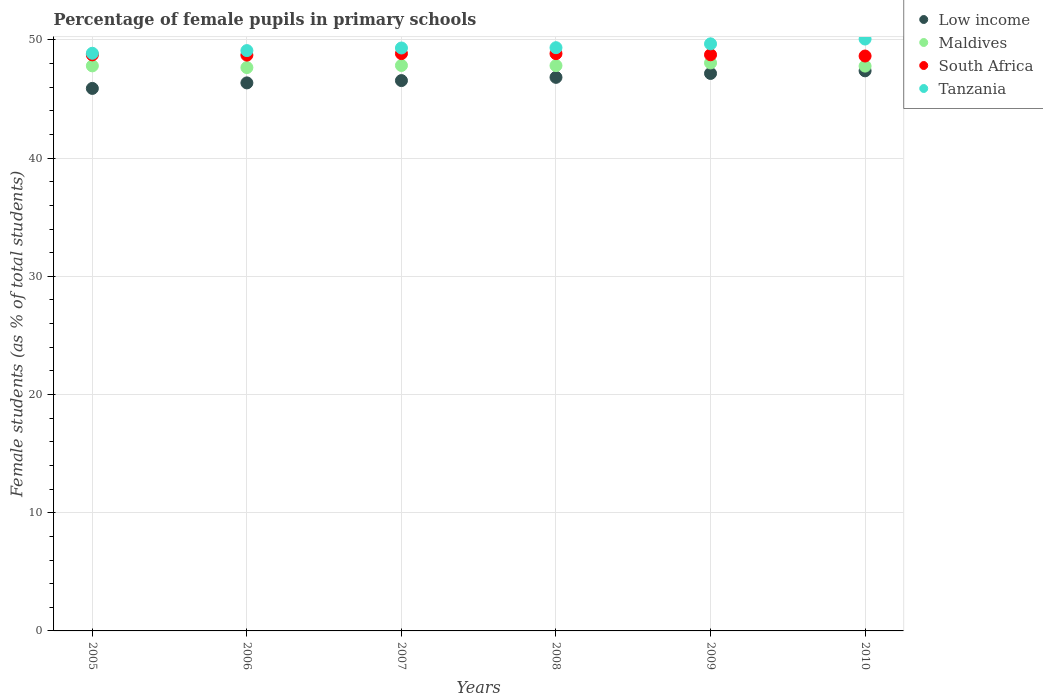How many different coloured dotlines are there?
Offer a terse response. 4. What is the percentage of female pupils in primary schools in Low income in 2007?
Offer a terse response. 46.56. Across all years, what is the maximum percentage of female pupils in primary schools in Low income?
Your answer should be very brief. 47.39. Across all years, what is the minimum percentage of female pupils in primary schools in South Africa?
Give a very brief answer. 48.64. In which year was the percentage of female pupils in primary schools in Maldives maximum?
Keep it short and to the point. 2009. What is the total percentage of female pupils in primary schools in South Africa in the graph?
Keep it short and to the point. 292.52. What is the difference between the percentage of female pupils in primary schools in Maldives in 2006 and that in 2009?
Provide a short and direct response. -0.39. What is the difference between the percentage of female pupils in primary schools in Low income in 2007 and the percentage of female pupils in primary schools in Tanzania in 2009?
Your answer should be very brief. -3.11. What is the average percentage of female pupils in primary schools in Maldives per year?
Your answer should be very brief. 47.83. In the year 2010, what is the difference between the percentage of female pupils in primary schools in Low income and percentage of female pupils in primary schools in Maldives?
Give a very brief answer. -0.4. In how many years, is the percentage of female pupils in primary schools in Low income greater than 2 %?
Your response must be concise. 6. What is the ratio of the percentage of female pupils in primary schools in Tanzania in 2006 to that in 2008?
Make the answer very short. 1. Is the percentage of female pupils in primary schools in Maldives in 2005 less than that in 2010?
Keep it short and to the point. No. Is the difference between the percentage of female pupils in primary schools in Low income in 2008 and 2010 greater than the difference between the percentage of female pupils in primary schools in Maldives in 2008 and 2010?
Offer a very short reply. No. What is the difference between the highest and the second highest percentage of female pupils in primary schools in Low income?
Make the answer very short. 0.22. What is the difference between the highest and the lowest percentage of female pupils in primary schools in Low income?
Provide a short and direct response. 1.49. In how many years, is the percentage of female pupils in primary schools in South Africa greater than the average percentage of female pupils in primary schools in South Africa taken over all years?
Make the answer very short. 2. Is the sum of the percentage of female pupils in primary schools in Low income in 2009 and 2010 greater than the maximum percentage of female pupils in primary schools in South Africa across all years?
Your answer should be very brief. Yes. Is it the case that in every year, the sum of the percentage of female pupils in primary schools in Low income and percentage of female pupils in primary schools in Maldives  is greater than the percentage of female pupils in primary schools in Tanzania?
Keep it short and to the point. Yes. Is the percentage of female pupils in primary schools in South Africa strictly greater than the percentage of female pupils in primary schools in Maldives over the years?
Offer a very short reply. Yes. Is the percentage of female pupils in primary schools in Tanzania strictly less than the percentage of female pupils in primary schools in Low income over the years?
Keep it short and to the point. No. What is the difference between two consecutive major ticks on the Y-axis?
Ensure brevity in your answer.  10. Does the graph contain grids?
Keep it short and to the point. Yes. How many legend labels are there?
Offer a very short reply. 4. What is the title of the graph?
Provide a short and direct response. Percentage of female pupils in primary schools. What is the label or title of the X-axis?
Provide a succinct answer. Years. What is the label or title of the Y-axis?
Make the answer very short. Female students (as % of total students). What is the Female students (as % of total students) in Low income in 2005?
Provide a short and direct response. 45.9. What is the Female students (as % of total students) of Maldives in 2005?
Your response must be concise. 47.81. What is the Female students (as % of total students) of South Africa in 2005?
Make the answer very short. 48.74. What is the Female students (as % of total students) in Tanzania in 2005?
Offer a terse response. 48.87. What is the Female students (as % of total students) in Low income in 2006?
Make the answer very short. 46.37. What is the Female students (as % of total students) in Maldives in 2006?
Keep it short and to the point. 47.66. What is the Female students (as % of total students) in South Africa in 2006?
Offer a terse response. 48.72. What is the Female students (as % of total students) in Tanzania in 2006?
Provide a succinct answer. 49.1. What is the Female students (as % of total students) in Low income in 2007?
Keep it short and to the point. 46.56. What is the Female students (as % of total students) in Maldives in 2007?
Provide a short and direct response. 47.84. What is the Female students (as % of total students) of South Africa in 2007?
Offer a terse response. 48.84. What is the Female students (as % of total students) in Tanzania in 2007?
Keep it short and to the point. 49.32. What is the Female students (as % of total students) in Low income in 2008?
Offer a terse response. 46.83. What is the Female students (as % of total students) of Maldives in 2008?
Ensure brevity in your answer.  47.83. What is the Female students (as % of total students) in South Africa in 2008?
Give a very brief answer. 48.84. What is the Female students (as % of total students) of Tanzania in 2008?
Offer a very short reply. 49.34. What is the Female students (as % of total students) of Low income in 2009?
Provide a succinct answer. 47.17. What is the Female students (as % of total students) in Maldives in 2009?
Make the answer very short. 48.05. What is the Female students (as % of total students) of South Africa in 2009?
Your answer should be compact. 48.75. What is the Female students (as % of total students) of Tanzania in 2009?
Offer a very short reply. 49.67. What is the Female students (as % of total students) of Low income in 2010?
Provide a short and direct response. 47.39. What is the Female students (as % of total students) of Maldives in 2010?
Ensure brevity in your answer.  47.79. What is the Female students (as % of total students) of South Africa in 2010?
Offer a very short reply. 48.64. What is the Female students (as % of total students) in Tanzania in 2010?
Ensure brevity in your answer.  50.08. Across all years, what is the maximum Female students (as % of total students) of Low income?
Keep it short and to the point. 47.39. Across all years, what is the maximum Female students (as % of total students) in Maldives?
Your answer should be compact. 48.05. Across all years, what is the maximum Female students (as % of total students) in South Africa?
Make the answer very short. 48.84. Across all years, what is the maximum Female students (as % of total students) of Tanzania?
Ensure brevity in your answer.  50.08. Across all years, what is the minimum Female students (as % of total students) in Low income?
Offer a terse response. 45.9. Across all years, what is the minimum Female students (as % of total students) of Maldives?
Offer a very short reply. 47.66. Across all years, what is the minimum Female students (as % of total students) in South Africa?
Keep it short and to the point. 48.64. Across all years, what is the minimum Female students (as % of total students) of Tanzania?
Offer a terse response. 48.87. What is the total Female students (as % of total students) of Low income in the graph?
Your answer should be very brief. 280.21. What is the total Female students (as % of total students) of Maldives in the graph?
Your answer should be very brief. 286.98. What is the total Female students (as % of total students) in South Africa in the graph?
Your answer should be very brief. 292.52. What is the total Female students (as % of total students) in Tanzania in the graph?
Your response must be concise. 296.38. What is the difference between the Female students (as % of total students) in Low income in 2005 and that in 2006?
Offer a terse response. -0.47. What is the difference between the Female students (as % of total students) of Maldives in 2005 and that in 2006?
Give a very brief answer. 0.14. What is the difference between the Female students (as % of total students) of South Africa in 2005 and that in 2006?
Provide a succinct answer. 0.02. What is the difference between the Female students (as % of total students) in Tanzania in 2005 and that in 2006?
Your answer should be compact. -0.23. What is the difference between the Female students (as % of total students) of Low income in 2005 and that in 2007?
Provide a succinct answer. -0.66. What is the difference between the Female students (as % of total students) of Maldives in 2005 and that in 2007?
Provide a succinct answer. -0.03. What is the difference between the Female students (as % of total students) of South Africa in 2005 and that in 2007?
Offer a terse response. -0.11. What is the difference between the Female students (as % of total students) in Tanzania in 2005 and that in 2007?
Your response must be concise. -0.45. What is the difference between the Female students (as % of total students) of Low income in 2005 and that in 2008?
Offer a terse response. -0.94. What is the difference between the Female students (as % of total students) of Maldives in 2005 and that in 2008?
Offer a terse response. -0.02. What is the difference between the Female students (as % of total students) of South Africa in 2005 and that in 2008?
Give a very brief answer. -0.1. What is the difference between the Female students (as % of total students) of Tanzania in 2005 and that in 2008?
Provide a short and direct response. -0.47. What is the difference between the Female students (as % of total students) of Low income in 2005 and that in 2009?
Offer a very short reply. -1.27. What is the difference between the Female students (as % of total students) of Maldives in 2005 and that in 2009?
Give a very brief answer. -0.25. What is the difference between the Female students (as % of total students) of South Africa in 2005 and that in 2009?
Ensure brevity in your answer.  -0.01. What is the difference between the Female students (as % of total students) in Tanzania in 2005 and that in 2009?
Give a very brief answer. -0.8. What is the difference between the Female students (as % of total students) in Low income in 2005 and that in 2010?
Your answer should be very brief. -1.49. What is the difference between the Female students (as % of total students) in Maldives in 2005 and that in 2010?
Ensure brevity in your answer.  0.02. What is the difference between the Female students (as % of total students) of South Africa in 2005 and that in 2010?
Offer a terse response. 0.1. What is the difference between the Female students (as % of total students) of Tanzania in 2005 and that in 2010?
Offer a terse response. -1.2. What is the difference between the Female students (as % of total students) of Low income in 2006 and that in 2007?
Provide a short and direct response. -0.2. What is the difference between the Female students (as % of total students) in Maldives in 2006 and that in 2007?
Ensure brevity in your answer.  -0.18. What is the difference between the Female students (as % of total students) in South Africa in 2006 and that in 2007?
Offer a very short reply. -0.13. What is the difference between the Female students (as % of total students) of Tanzania in 2006 and that in 2007?
Offer a terse response. -0.22. What is the difference between the Female students (as % of total students) of Low income in 2006 and that in 2008?
Your response must be concise. -0.47. What is the difference between the Female students (as % of total students) in Maldives in 2006 and that in 2008?
Provide a succinct answer. -0.16. What is the difference between the Female students (as % of total students) of South Africa in 2006 and that in 2008?
Make the answer very short. -0.12. What is the difference between the Female students (as % of total students) of Tanzania in 2006 and that in 2008?
Provide a succinct answer. -0.25. What is the difference between the Female students (as % of total students) of Low income in 2006 and that in 2009?
Your response must be concise. -0.8. What is the difference between the Female students (as % of total students) of Maldives in 2006 and that in 2009?
Ensure brevity in your answer.  -0.39. What is the difference between the Female students (as % of total students) of South Africa in 2006 and that in 2009?
Provide a short and direct response. -0.03. What is the difference between the Female students (as % of total students) in Tanzania in 2006 and that in 2009?
Offer a very short reply. -0.57. What is the difference between the Female students (as % of total students) of Low income in 2006 and that in 2010?
Offer a very short reply. -1.02. What is the difference between the Female students (as % of total students) of Maldives in 2006 and that in 2010?
Your answer should be very brief. -0.12. What is the difference between the Female students (as % of total students) in South Africa in 2006 and that in 2010?
Provide a short and direct response. 0.08. What is the difference between the Female students (as % of total students) in Tanzania in 2006 and that in 2010?
Keep it short and to the point. -0.98. What is the difference between the Female students (as % of total students) in Low income in 2007 and that in 2008?
Give a very brief answer. -0.27. What is the difference between the Female students (as % of total students) in Maldives in 2007 and that in 2008?
Ensure brevity in your answer.  0.01. What is the difference between the Female students (as % of total students) of South Africa in 2007 and that in 2008?
Your response must be concise. 0. What is the difference between the Female students (as % of total students) of Tanzania in 2007 and that in 2008?
Provide a short and direct response. -0.03. What is the difference between the Female students (as % of total students) in Low income in 2007 and that in 2009?
Offer a very short reply. -0.6. What is the difference between the Female students (as % of total students) in Maldives in 2007 and that in 2009?
Your answer should be very brief. -0.21. What is the difference between the Female students (as % of total students) of South Africa in 2007 and that in 2009?
Your answer should be compact. 0.1. What is the difference between the Female students (as % of total students) in Tanzania in 2007 and that in 2009?
Provide a succinct answer. -0.35. What is the difference between the Female students (as % of total students) of Low income in 2007 and that in 2010?
Make the answer very short. -0.82. What is the difference between the Female students (as % of total students) in Maldives in 2007 and that in 2010?
Make the answer very short. 0.05. What is the difference between the Female students (as % of total students) in South Africa in 2007 and that in 2010?
Your answer should be very brief. 0.21. What is the difference between the Female students (as % of total students) in Tanzania in 2007 and that in 2010?
Your response must be concise. -0.76. What is the difference between the Female students (as % of total students) in Low income in 2008 and that in 2009?
Offer a very short reply. -0.33. What is the difference between the Female students (as % of total students) of Maldives in 2008 and that in 2009?
Offer a very short reply. -0.23. What is the difference between the Female students (as % of total students) in South Africa in 2008 and that in 2009?
Your answer should be very brief. 0.1. What is the difference between the Female students (as % of total students) in Tanzania in 2008 and that in 2009?
Your answer should be very brief. -0.32. What is the difference between the Female students (as % of total students) in Low income in 2008 and that in 2010?
Provide a short and direct response. -0.55. What is the difference between the Female students (as % of total students) of Maldives in 2008 and that in 2010?
Make the answer very short. 0.04. What is the difference between the Female students (as % of total students) of South Africa in 2008 and that in 2010?
Offer a very short reply. 0.2. What is the difference between the Female students (as % of total students) of Tanzania in 2008 and that in 2010?
Provide a short and direct response. -0.73. What is the difference between the Female students (as % of total students) of Low income in 2009 and that in 2010?
Make the answer very short. -0.22. What is the difference between the Female students (as % of total students) in Maldives in 2009 and that in 2010?
Offer a very short reply. 0.27. What is the difference between the Female students (as % of total students) in South Africa in 2009 and that in 2010?
Ensure brevity in your answer.  0.11. What is the difference between the Female students (as % of total students) in Tanzania in 2009 and that in 2010?
Provide a short and direct response. -0.41. What is the difference between the Female students (as % of total students) in Low income in 2005 and the Female students (as % of total students) in Maldives in 2006?
Your answer should be compact. -1.76. What is the difference between the Female students (as % of total students) of Low income in 2005 and the Female students (as % of total students) of South Africa in 2006?
Keep it short and to the point. -2.82. What is the difference between the Female students (as % of total students) of Low income in 2005 and the Female students (as % of total students) of Tanzania in 2006?
Your response must be concise. -3.2. What is the difference between the Female students (as % of total students) in Maldives in 2005 and the Female students (as % of total students) in South Africa in 2006?
Offer a terse response. -0.91. What is the difference between the Female students (as % of total students) of Maldives in 2005 and the Female students (as % of total students) of Tanzania in 2006?
Ensure brevity in your answer.  -1.29. What is the difference between the Female students (as % of total students) of South Africa in 2005 and the Female students (as % of total students) of Tanzania in 2006?
Keep it short and to the point. -0.36. What is the difference between the Female students (as % of total students) in Low income in 2005 and the Female students (as % of total students) in Maldives in 2007?
Your answer should be very brief. -1.94. What is the difference between the Female students (as % of total students) in Low income in 2005 and the Female students (as % of total students) in South Africa in 2007?
Your answer should be compact. -2.95. What is the difference between the Female students (as % of total students) in Low income in 2005 and the Female students (as % of total students) in Tanzania in 2007?
Offer a terse response. -3.42. What is the difference between the Female students (as % of total students) of Maldives in 2005 and the Female students (as % of total students) of South Africa in 2007?
Provide a short and direct response. -1.04. What is the difference between the Female students (as % of total students) of Maldives in 2005 and the Female students (as % of total students) of Tanzania in 2007?
Your answer should be very brief. -1.51. What is the difference between the Female students (as % of total students) in South Africa in 2005 and the Female students (as % of total students) in Tanzania in 2007?
Keep it short and to the point. -0.58. What is the difference between the Female students (as % of total students) of Low income in 2005 and the Female students (as % of total students) of Maldives in 2008?
Your answer should be very brief. -1.93. What is the difference between the Female students (as % of total students) of Low income in 2005 and the Female students (as % of total students) of South Africa in 2008?
Your answer should be compact. -2.94. What is the difference between the Female students (as % of total students) of Low income in 2005 and the Female students (as % of total students) of Tanzania in 2008?
Offer a terse response. -3.45. What is the difference between the Female students (as % of total students) in Maldives in 2005 and the Female students (as % of total students) in South Africa in 2008?
Your answer should be very brief. -1.03. What is the difference between the Female students (as % of total students) of Maldives in 2005 and the Female students (as % of total students) of Tanzania in 2008?
Provide a short and direct response. -1.54. What is the difference between the Female students (as % of total students) of South Africa in 2005 and the Female students (as % of total students) of Tanzania in 2008?
Keep it short and to the point. -0.61. What is the difference between the Female students (as % of total students) in Low income in 2005 and the Female students (as % of total students) in Maldives in 2009?
Keep it short and to the point. -2.16. What is the difference between the Female students (as % of total students) of Low income in 2005 and the Female students (as % of total students) of South Africa in 2009?
Provide a succinct answer. -2.85. What is the difference between the Female students (as % of total students) of Low income in 2005 and the Female students (as % of total students) of Tanzania in 2009?
Provide a short and direct response. -3.77. What is the difference between the Female students (as % of total students) of Maldives in 2005 and the Female students (as % of total students) of South Africa in 2009?
Provide a succinct answer. -0.94. What is the difference between the Female students (as % of total students) in Maldives in 2005 and the Female students (as % of total students) in Tanzania in 2009?
Give a very brief answer. -1.86. What is the difference between the Female students (as % of total students) of South Africa in 2005 and the Female students (as % of total students) of Tanzania in 2009?
Make the answer very short. -0.93. What is the difference between the Female students (as % of total students) of Low income in 2005 and the Female students (as % of total students) of Maldives in 2010?
Offer a terse response. -1.89. What is the difference between the Female students (as % of total students) of Low income in 2005 and the Female students (as % of total students) of South Africa in 2010?
Your answer should be compact. -2.74. What is the difference between the Female students (as % of total students) in Low income in 2005 and the Female students (as % of total students) in Tanzania in 2010?
Provide a succinct answer. -4.18. What is the difference between the Female students (as % of total students) in Maldives in 2005 and the Female students (as % of total students) in South Africa in 2010?
Give a very brief answer. -0.83. What is the difference between the Female students (as % of total students) of Maldives in 2005 and the Female students (as % of total students) of Tanzania in 2010?
Make the answer very short. -2.27. What is the difference between the Female students (as % of total students) of South Africa in 2005 and the Female students (as % of total students) of Tanzania in 2010?
Offer a terse response. -1.34. What is the difference between the Female students (as % of total students) in Low income in 2006 and the Female students (as % of total students) in Maldives in 2007?
Offer a very short reply. -1.47. What is the difference between the Female students (as % of total students) in Low income in 2006 and the Female students (as % of total students) in South Africa in 2007?
Your answer should be very brief. -2.48. What is the difference between the Female students (as % of total students) of Low income in 2006 and the Female students (as % of total students) of Tanzania in 2007?
Offer a very short reply. -2.95. What is the difference between the Female students (as % of total students) in Maldives in 2006 and the Female students (as % of total students) in South Africa in 2007?
Your answer should be compact. -1.18. What is the difference between the Female students (as % of total students) of Maldives in 2006 and the Female students (as % of total students) of Tanzania in 2007?
Offer a terse response. -1.66. What is the difference between the Female students (as % of total students) of South Africa in 2006 and the Female students (as % of total students) of Tanzania in 2007?
Keep it short and to the point. -0.6. What is the difference between the Female students (as % of total students) in Low income in 2006 and the Female students (as % of total students) in Maldives in 2008?
Your answer should be compact. -1.46. What is the difference between the Female students (as % of total students) of Low income in 2006 and the Female students (as % of total students) of South Africa in 2008?
Provide a short and direct response. -2.48. What is the difference between the Female students (as % of total students) in Low income in 2006 and the Female students (as % of total students) in Tanzania in 2008?
Your answer should be compact. -2.98. What is the difference between the Female students (as % of total students) in Maldives in 2006 and the Female students (as % of total students) in South Africa in 2008?
Ensure brevity in your answer.  -1.18. What is the difference between the Female students (as % of total students) in Maldives in 2006 and the Female students (as % of total students) in Tanzania in 2008?
Keep it short and to the point. -1.68. What is the difference between the Female students (as % of total students) in South Africa in 2006 and the Female students (as % of total students) in Tanzania in 2008?
Provide a short and direct response. -0.63. What is the difference between the Female students (as % of total students) in Low income in 2006 and the Female students (as % of total students) in Maldives in 2009?
Give a very brief answer. -1.69. What is the difference between the Female students (as % of total students) in Low income in 2006 and the Female students (as % of total students) in South Africa in 2009?
Ensure brevity in your answer.  -2.38. What is the difference between the Female students (as % of total students) of Low income in 2006 and the Female students (as % of total students) of Tanzania in 2009?
Your answer should be very brief. -3.3. What is the difference between the Female students (as % of total students) in Maldives in 2006 and the Female students (as % of total students) in South Africa in 2009?
Provide a succinct answer. -1.08. What is the difference between the Female students (as % of total students) of Maldives in 2006 and the Female students (as % of total students) of Tanzania in 2009?
Keep it short and to the point. -2.01. What is the difference between the Female students (as % of total students) in South Africa in 2006 and the Female students (as % of total students) in Tanzania in 2009?
Give a very brief answer. -0.95. What is the difference between the Female students (as % of total students) of Low income in 2006 and the Female students (as % of total students) of Maldives in 2010?
Provide a short and direct response. -1.42. What is the difference between the Female students (as % of total students) in Low income in 2006 and the Female students (as % of total students) in South Africa in 2010?
Your answer should be compact. -2.27. What is the difference between the Female students (as % of total students) in Low income in 2006 and the Female students (as % of total students) in Tanzania in 2010?
Keep it short and to the point. -3.71. What is the difference between the Female students (as % of total students) of Maldives in 2006 and the Female students (as % of total students) of South Africa in 2010?
Keep it short and to the point. -0.98. What is the difference between the Female students (as % of total students) in Maldives in 2006 and the Female students (as % of total students) in Tanzania in 2010?
Your response must be concise. -2.41. What is the difference between the Female students (as % of total students) of South Africa in 2006 and the Female students (as % of total students) of Tanzania in 2010?
Your response must be concise. -1.36. What is the difference between the Female students (as % of total students) of Low income in 2007 and the Female students (as % of total students) of Maldives in 2008?
Provide a short and direct response. -1.27. What is the difference between the Female students (as % of total students) in Low income in 2007 and the Female students (as % of total students) in South Africa in 2008?
Your answer should be very brief. -2.28. What is the difference between the Female students (as % of total students) in Low income in 2007 and the Female students (as % of total students) in Tanzania in 2008?
Make the answer very short. -2.78. What is the difference between the Female students (as % of total students) in Maldives in 2007 and the Female students (as % of total students) in South Africa in 2008?
Give a very brief answer. -1. What is the difference between the Female students (as % of total students) in Maldives in 2007 and the Female students (as % of total students) in Tanzania in 2008?
Your response must be concise. -1.5. What is the difference between the Female students (as % of total students) of South Africa in 2007 and the Female students (as % of total students) of Tanzania in 2008?
Give a very brief answer. -0.5. What is the difference between the Female students (as % of total students) of Low income in 2007 and the Female students (as % of total students) of Maldives in 2009?
Make the answer very short. -1.49. What is the difference between the Female students (as % of total students) of Low income in 2007 and the Female students (as % of total students) of South Africa in 2009?
Provide a succinct answer. -2.18. What is the difference between the Female students (as % of total students) in Low income in 2007 and the Female students (as % of total students) in Tanzania in 2009?
Make the answer very short. -3.11. What is the difference between the Female students (as % of total students) of Maldives in 2007 and the Female students (as % of total students) of South Africa in 2009?
Offer a very short reply. -0.91. What is the difference between the Female students (as % of total students) in Maldives in 2007 and the Female students (as % of total students) in Tanzania in 2009?
Your response must be concise. -1.83. What is the difference between the Female students (as % of total students) in South Africa in 2007 and the Female students (as % of total students) in Tanzania in 2009?
Provide a succinct answer. -0.82. What is the difference between the Female students (as % of total students) of Low income in 2007 and the Female students (as % of total students) of Maldives in 2010?
Offer a very short reply. -1.23. What is the difference between the Female students (as % of total students) in Low income in 2007 and the Female students (as % of total students) in South Africa in 2010?
Ensure brevity in your answer.  -2.08. What is the difference between the Female students (as % of total students) in Low income in 2007 and the Female students (as % of total students) in Tanzania in 2010?
Offer a terse response. -3.51. What is the difference between the Female students (as % of total students) in Maldives in 2007 and the Female students (as % of total students) in South Africa in 2010?
Give a very brief answer. -0.8. What is the difference between the Female students (as % of total students) in Maldives in 2007 and the Female students (as % of total students) in Tanzania in 2010?
Your answer should be compact. -2.24. What is the difference between the Female students (as % of total students) of South Africa in 2007 and the Female students (as % of total students) of Tanzania in 2010?
Your answer should be compact. -1.23. What is the difference between the Female students (as % of total students) of Low income in 2008 and the Female students (as % of total students) of Maldives in 2009?
Provide a short and direct response. -1.22. What is the difference between the Female students (as % of total students) in Low income in 2008 and the Female students (as % of total students) in South Africa in 2009?
Give a very brief answer. -1.91. What is the difference between the Female students (as % of total students) in Low income in 2008 and the Female students (as % of total students) in Tanzania in 2009?
Ensure brevity in your answer.  -2.83. What is the difference between the Female students (as % of total students) in Maldives in 2008 and the Female students (as % of total students) in South Africa in 2009?
Provide a short and direct response. -0.92. What is the difference between the Female students (as % of total students) in Maldives in 2008 and the Female students (as % of total students) in Tanzania in 2009?
Ensure brevity in your answer.  -1.84. What is the difference between the Female students (as % of total students) in South Africa in 2008 and the Female students (as % of total students) in Tanzania in 2009?
Keep it short and to the point. -0.83. What is the difference between the Female students (as % of total students) of Low income in 2008 and the Female students (as % of total students) of Maldives in 2010?
Your response must be concise. -0.95. What is the difference between the Female students (as % of total students) of Low income in 2008 and the Female students (as % of total students) of South Africa in 2010?
Provide a succinct answer. -1.8. What is the difference between the Female students (as % of total students) of Low income in 2008 and the Female students (as % of total students) of Tanzania in 2010?
Provide a succinct answer. -3.24. What is the difference between the Female students (as % of total students) of Maldives in 2008 and the Female students (as % of total students) of South Africa in 2010?
Keep it short and to the point. -0.81. What is the difference between the Female students (as % of total students) in Maldives in 2008 and the Female students (as % of total students) in Tanzania in 2010?
Give a very brief answer. -2.25. What is the difference between the Female students (as % of total students) in South Africa in 2008 and the Female students (as % of total students) in Tanzania in 2010?
Your answer should be very brief. -1.24. What is the difference between the Female students (as % of total students) in Low income in 2009 and the Female students (as % of total students) in Maldives in 2010?
Keep it short and to the point. -0.62. What is the difference between the Female students (as % of total students) of Low income in 2009 and the Female students (as % of total students) of South Africa in 2010?
Your answer should be very brief. -1.47. What is the difference between the Female students (as % of total students) in Low income in 2009 and the Female students (as % of total students) in Tanzania in 2010?
Provide a succinct answer. -2.91. What is the difference between the Female students (as % of total students) of Maldives in 2009 and the Female students (as % of total students) of South Africa in 2010?
Ensure brevity in your answer.  -0.59. What is the difference between the Female students (as % of total students) of Maldives in 2009 and the Female students (as % of total students) of Tanzania in 2010?
Offer a very short reply. -2.02. What is the difference between the Female students (as % of total students) in South Africa in 2009 and the Female students (as % of total students) in Tanzania in 2010?
Your response must be concise. -1.33. What is the average Female students (as % of total students) of Low income per year?
Provide a succinct answer. 46.7. What is the average Female students (as % of total students) of Maldives per year?
Provide a short and direct response. 47.83. What is the average Female students (as % of total students) of South Africa per year?
Offer a very short reply. 48.75. What is the average Female students (as % of total students) in Tanzania per year?
Provide a short and direct response. 49.4. In the year 2005, what is the difference between the Female students (as % of total students) in Low income and Female students (as % of total students) in Maldives?
Offer a terse response. -1.91. In the year 2005, what is the difference between the Female students (as % of total students) of Low income and Female students (as % of total students) of South Africa?
Offer a terse response. -2.84. In the year 2005, what is the difference between the Female students (as % of total students) of Low income and Female students (as % of total students) of Tanzania?
Ensure brevity in your answer.  -2.97. In the year 2005, what is the difference between the Female students (as % of total students) in Maldives and Female students (as % of total students) in South Africa?
Provide a short and direct response. -0.93. In the year 2005, what is the difference between the Female students (as % of total students) in Maldives and Female students (as % of total students) in Tanzania?
Give a very brief answer. -1.06. In the year 2005, what is the difference between the Female students (as % of total students) of South Africa and Female students (as % of total students) of Tanzania?
Offer a terse response. -0.13. In the year 2006, what is the difference between the Female students (as % of total students) of Low income and Female students (as % of total students) of Maldives?
Make the answer very short. -1.3. In the year 2006, what is the difference between the Female students (as % of total students) of Low income and Female students (as % of total students) of South Africa?
Keep it short and to the point. -2.35. In the year 2006, what is the difference between the Female students (as % of total students) in Low income and Female students (as % of total students) in Tanzania?
Your answer should be compact. -2.73. In the year 2006, what is the difference between the Female students (as % of total students) in Maldives and Female students (as % of total students) in South Africa?
Give a very brief answer. -1.05. In the year 2006, what is the difference between the Female students (as % of total students) in Maldives and Female students (as % of total students) in Tanzania?
Ensure brevity in your answer.  -1.44. In the year 2006, what is the difference between the Female students (as % of total students) of South Africa and Female students (as % of total students) of Tanzania?
Give a very brief answer. -0.38. In the year 2007, what is the difference between the Female students (as % of total students) in Low income and Female students (as % of total students) in Maldives?
Offer a terse response. -1.28. In the year 2007, what is the difference between the Female students (as % of total students) in Low income and Female students (as % of total students) in South Africa?
Make the answer very short. -2.28. In the year 2007, what is the difference between the Female students (as % of total students) in Low income and Female students (as % of total students) in Tanzania?
Ensure brevity in your answer.  -2.76. In the year 2007, what is the difference between the Female students (as % of total students) of Maldives and Female students (as % of total students) of South Africa?
Ensure brevity in your answer.  -1. In the year 2007, what is the difference between the Female students (as % of total students) of Maldives and Female students (as % of total students) of Tanzania?
Provide a short and direct response. -1.48. In the year 2007, what is the difference between the Female students (as % of total students) of South Africa and Female students (as % of total students) of Tanzania?
Make the answer very short. -0.47. In the year 2008, what is the difference between the Female students (as % of total students) in Low income and Female students (as % of total students) in Maldives?
Make the answer very short. -0.99. In the year 2008, what is the difference between the Female students (as % of total students) of Low income and Female students (as % of total students) of South Africa?
Your answer should be very brief. -2.01. In the year 2008, what is the difference between the Female students (as % of total students) of Low income and Female students (as % of total students) of Tanzania?
Provide a short and direct response. -2.51. In the year 2008, what is the difference between the Female students (as % of total students) of Maldives and Female students (as % of total students) of South Africa?
Offer a very short reply. -1.01. In the year 2008, what is the difference between the Female students (as % of total students) of Maldives and Female students (as % of total students) of Tanzania?
Your answer should be very brief. -1.52. In the year 2008, what is the difference between the Female students (as % of total students) in South Africa and Female students (as % of total students) in Tanzania?
Ensure brevity in your answer.  -0.5. In the year 2009, what is the difference between the Female students (as % of total students) in Low income and Female students (as % of total students) in Maldives?
Make the answer very short. -0.89. In the year 2009, what is the difference between the Female students (as % of total students) of Low income and Female students (as % of total students) of South Africa?
Your answer should be very brief. -1.58. In the year 2009, what is the difference between the Female students (as % of total students) in Low income and Female students (as % of total students) in Tanzania?
Make the answer very short. -2.5. In the year 2009, what is the difference between the Female students (as % of total students) in Maldives and Female students (as % of total students) in South Africa?
Make the answer very short. -0.69. In the year 2009, what is the difference between the Female students (as % of total students) in Maldives and Female students (as % of total students) in Tanzania?
Make the answer very short. -1.61. In the year 2009, what is the difference between the Female students (as % of total students) in South Africa and Female students (as % of total students) in Tanzania?
Give a very brief answer. -0.92. In the year 2010, what is the difference between the Female students (as % of total students) in Low income and Female students (as % of total students) in Maldives?
Provide a succinct answer. -0.4. In the year 2010, what is the difference between the Female students (as % of total students) in Low income and Female students (as % of total students) in South Africa?
Provide a succinct answer. -1.25. In the year 2010, what is the difference between the Female students (as % of total students) in Low income and Female students (as % of total students) in Tanzania?
Your response must be concise. -2.69. In the year 2010, what is the difference between the Female students (as % of total students) of Maldives and Female students (as % of total students) of South Africa?
Your answer should be compact. -0.85. In the year 2010, what is the difference between the Female students (as % of total students) of Maldives and Female students (as % of total students) of Tanzania?
Keep it short and to the point. -2.29. In the year 2010, what is the difference between the Female students (as % of total students) of South Africa and Female students (as % of total students) of Tanzania?
Your response must be concise. -1.44. What is the ratio of the Female students (as % of total students) of Low income in 2005 to that in 2006?
Your answer should be compact. 0.99. What is the ratio of the Female students (as % of total students) of South Africa in 2005 to that in 2006?
Ensure brevity in your answer.  1. What is the ratio of the Female students (as % of total students) in Low income in 2005 to that in 2007?
Your answer should be very brief. 0.99. What is the ratio of the Female students (as % of total students) of Tanzania in 2005 to that in 2007?
Offer a very short reply. 0.99. What is the ratio of the Female students (as % of total students) in Low income in 2005 to that in 2009?
Give a very brief answer. 0.97. What is the ratio of the Female students (as % of total students) in Maldives in 2005 to that in 2009?
Offer a very short reply. 0.99. What is the ratio of the Female students (as % of total students) of South Africa in 2005 to that in 2009?
Keep it short and to the point. 1. What is the ratio of the Female students (as % of total students) of Low income in 2005 to that in 2010?
Provide a succinct answer. 0.97. What is the ratio of the Female students (as % of total students) in Maldives in 2005 to that in 2010?
Your answer should be compact. 1. What is the ratio of the Female students (as % of total students) of South Africa in 2005 to that in 2010?
Your answer should be compact. 1. What is the ratio of the Female students (as % of total students) in Tanzania in 2005 to that in 2010?
Your answer should be very brief. 0.98. What is the ratio of the Female students (as % of total students) in Low income in 2006 to that in 2007?
Keep it short and to the point. 1. What is the ratio of the Female students (as % of total students) in South Africa in 2006 to that in 2007?
Keep it short and to the point. 1. What is the ratio of the Female students (as % of total students) in Tanzania in 2006 to that in 2007?
Your response must be concise. 1. What is the ratio of the Female students (as % of total students) in Low income in 2006 to that in 2008?
Give a very brief answer. 0.99. What is the ratio of the Female students (as % of total students) in Tanzania in 2006 to that in 2008?
Your answer should be very brief. 0.99. What is the ratio of the Female students (as % of total students) in South Africa in 2006 to that in 2009?
Your answer should be compact. 1. What is the ratio of the Female students (as % of total students) in Low income in 2006 to that in 2010?
Give a very brief answer. 0.98. What is the ratio of the Female students (as % of total students) in Maldives in 2006 to that in 2010?
Your response must be concise. 1. What is the ratio of the Female students (as % of total students) of Tanzania in 2006 to that in 2010?
Your answer should be compact. 0.98. What is the ratio of the Female students (as % of total students) of Maldives in 2007 to that in 2008?
Offer a very short reply. 1. What is the ratio of the Female students (as % of total students) of South Africa in 2007 to that in 2008?
Keep it short and to the point. 1. What is the ratio of the Female students (as % of total students) in Tanzania in 2007 to that in 2008?
Your answer should be very brief. 1. What is the ratio of the Female students (as % of total students) of Low income in 2007 to that in 2009?
Your response must be concise. 0.99. What is the ratio of the Female students (as % of total students) of South Africa in 2007 to that in 2009?
Your response must be concise. 1. What is the ratio of the Female students (as % of total students) of Tanzania in 2007 to that in 2009?
Your answer should be compact. 0.99. What is the ratio of the Female students (as % of total students) in Low income in 2007 to that in 2010?
Give a very brief answer. 0.98. What is the ratio of the Female students (as % of total students) of South Africa in 2007 to that in 2010?
Provide a succinct answer. 1. What is the ratio of the Female students (as % of total students) in Tanzania in 2007 to that in 2010?
Provide a succinct answer. 0.98. What is the ratio of the Female students (as % of total students) in Low income in 2008 to that in 2009?
Give a very brief answer. 0.99. What is the ratio of the Female students (as % of total students) of Maldives in 2008 to that in 2009?
Provide a succinct answer. 1. What is the ratio of the Female students (as % of total students) of South Africa in 2008 to that in 2009?
Your answer should be very brief. 1. What is the ratio of the Female students (as % of total students) of Tanzania in 2008 to that in 2009?
Ensure brevity in your answer.  0.99. What is the ratio of the Female students (as % of total students) of Low income in 2008 to that in 2010?
Ensure brevity in your answer.  0.99. What is the ratio of the Female students (as % of total students) in Tanzania in 2008 to that in 2010?
Keep it short and to the point. 0.99. What is the ratio of the Female students (as % of total students) in Maldives in 2009 to that in 2010?
Offer a very short reply. 1.01. What is the ratio of the Female students (as % of total students) of Tanzania in 2009 to that in 2010?
Your answer should be very brief. 0.99. What is the difference between the highest and the second highest Female students (as % of total students) in Low income?
Keep it short and to the point. 0.22. What is the difference between the highest and the second highest Female students (as % of total students) in Maldives?
Your answer should be very brief. 0.21. What is the difference between the highest and the second highest Female students (as % of total students) in South Africa?
Ensure brevity in your answer.  0. What is the difference between the highest and the second highest Female students (as % of total students) in Tanzania?
Offer a very short reply. 0.41. What is the difference between the highest and the lowest Female students (as % of total students) of Low income?
Your answer should be compact. 1.49. What is the difference between the highest and the lowest Female students (as % of total students) of Maldives?
Offer a terse response. 0.39. What is the difference between the highest and the lowest Female students (as % of total students) in South Africa?
Provide a succinct answer. 0.21. What is the difference between the highest and the lowest Female students (as % of total students) in Tanzania?
Your response must be concise. 1.2. 